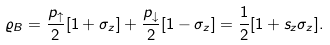Convert formula to latex. <formula><loc_0><loc_0><loc_500><loc_500>\varrho _ { B } = \frac { p _ { \uparrow } } { 2 } [ 1 + \sigma _ { z } ] + \frac { p _ { \downarrow } } { 2 } [ 1 - \sigma _ { z } ] = \frac { 1 } { 2 } [ 1 + s _ { z } \sigma _ { z } ] .</formula> 